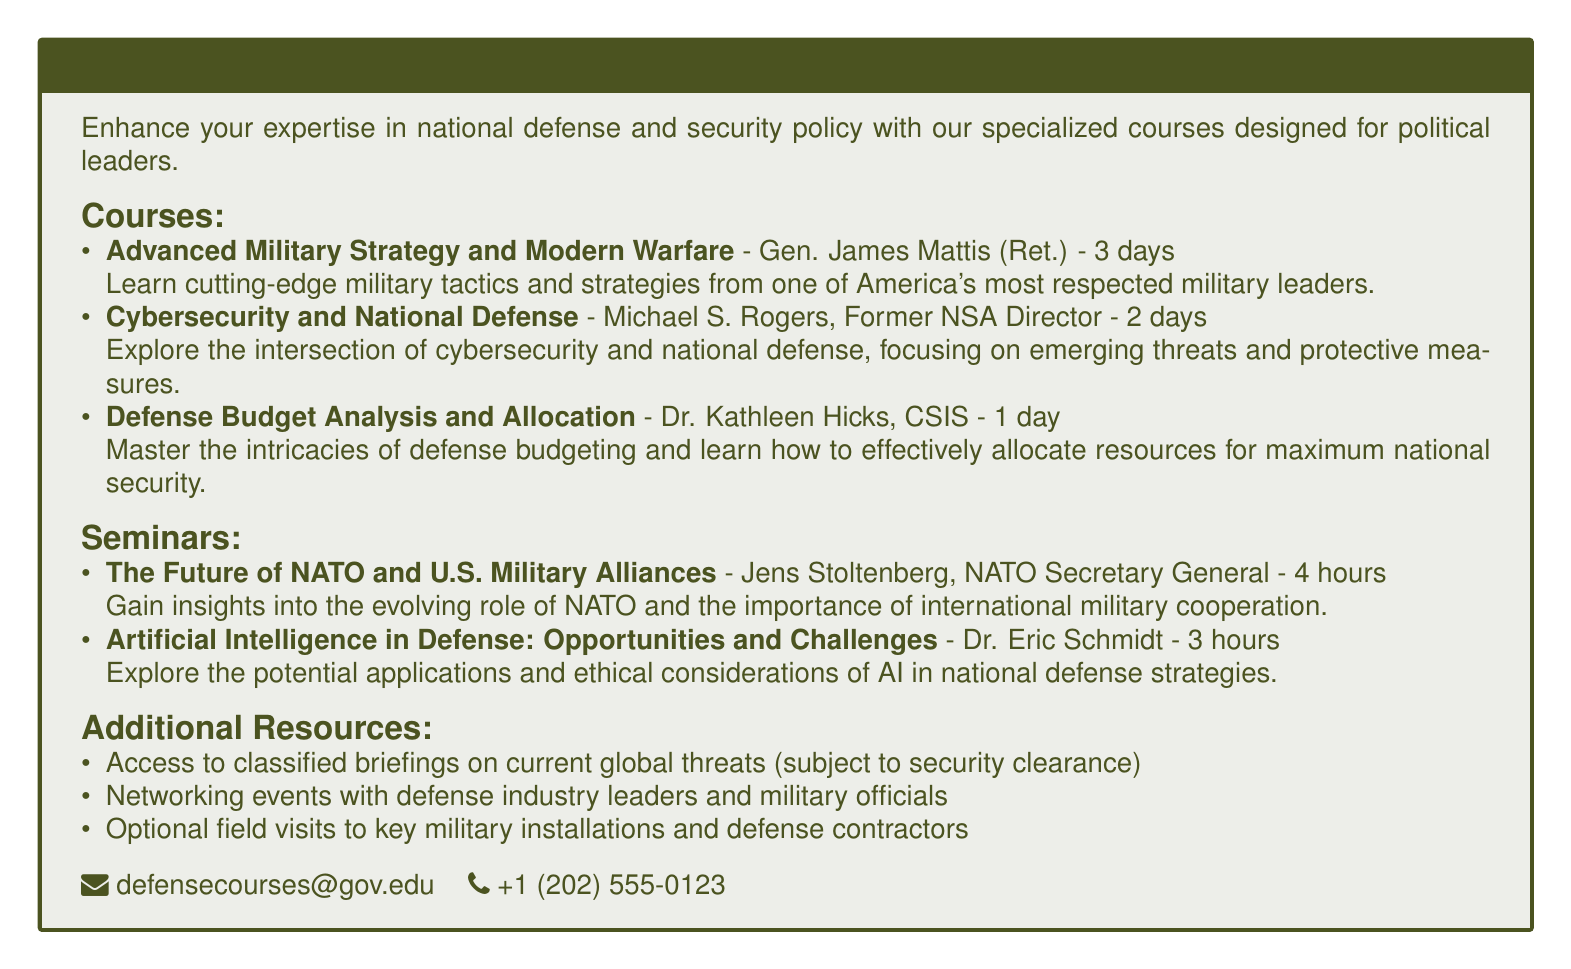What is the title of the catalog? The title can be found in the header of the document and indicates the focus of the professional development courses offered.
Answer: National Security and Defense Strategy: Professional Development for Politicians Who is the instructor for the course on Advanced Military Strategy and Modern Warfare? The document lists the instructor's name associated with each course, giving insight into their qualifications.
Answer: Gen. James Mattis (Ret.) How long is the Cybersecurity and National Defense course? The duration of each course is specified, allowing potential participants to gauge their time commitment.
Answer: 2 days What is one of the topics covered in the seminar by Jens Stoltenberg? The seminars include key themes and topics discussed by recognized experts in national security.
Answer: The Future of NATO and U.S. Military Alliances What additional resource is provided subject to security clearance? The document mentions various resources, including classified information, to enhance participants' understanding of national defense.
Answer: Access to classified briefings on current global threats How long is the seminar on Artificial Intelligence in Defense? The duration of each seminar is provided, indicating how intensive each session is.
Answer: 3 hours What is the phone number listed for inquiries about the courses? Contact information is typically essential in catalogs for ease of communication regarding questions or enrollment.
Answer: +1 (202) 555-0123 How many days does the Defense Budget Analysis and Allocation course last? The specific length of the course is detailed in the course descriptions, aiding in scheduling.
Answer: 1 day 